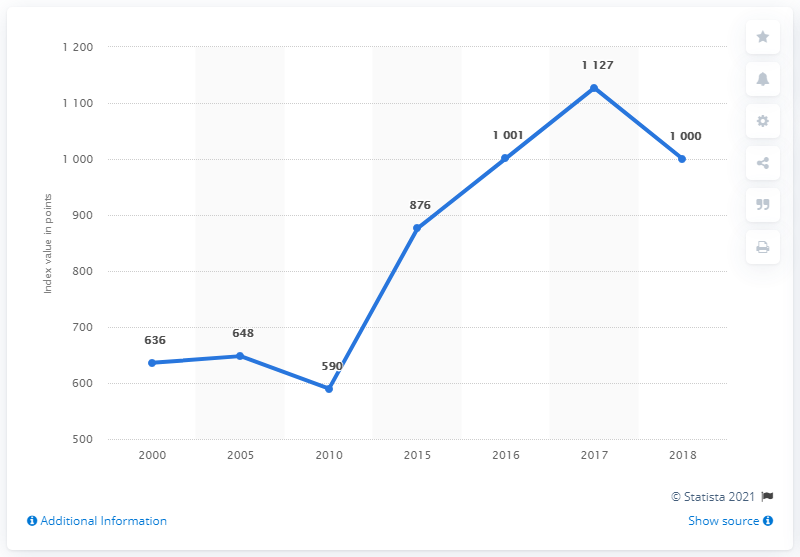Identify some key points in this picture. The line graph contains 2 drops. During the past century, the S&P 500 has experienced significant fluctuations in its value. To quantify these changes, we can divide the best annual increase in the S&P 500 by the worst annual drop in a single year. This calculation results in a ratio of 2.25. 